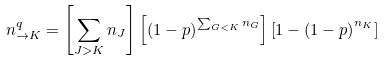Convert formula to latex. <formula><loc_0><loc_0><loc_500><loc_500>n ^ { q } _ { \rightarrow K } = \left [ \sum _ { J > K } n _ { J } \right ] \left [ \left ( 1 - p \right ) ^ { \sum _ { G < K } n _ { G } } \right ] \left [ 1 - \left ( 1 - p \right ) ^ { n _ { K } } \right ]</formula> 